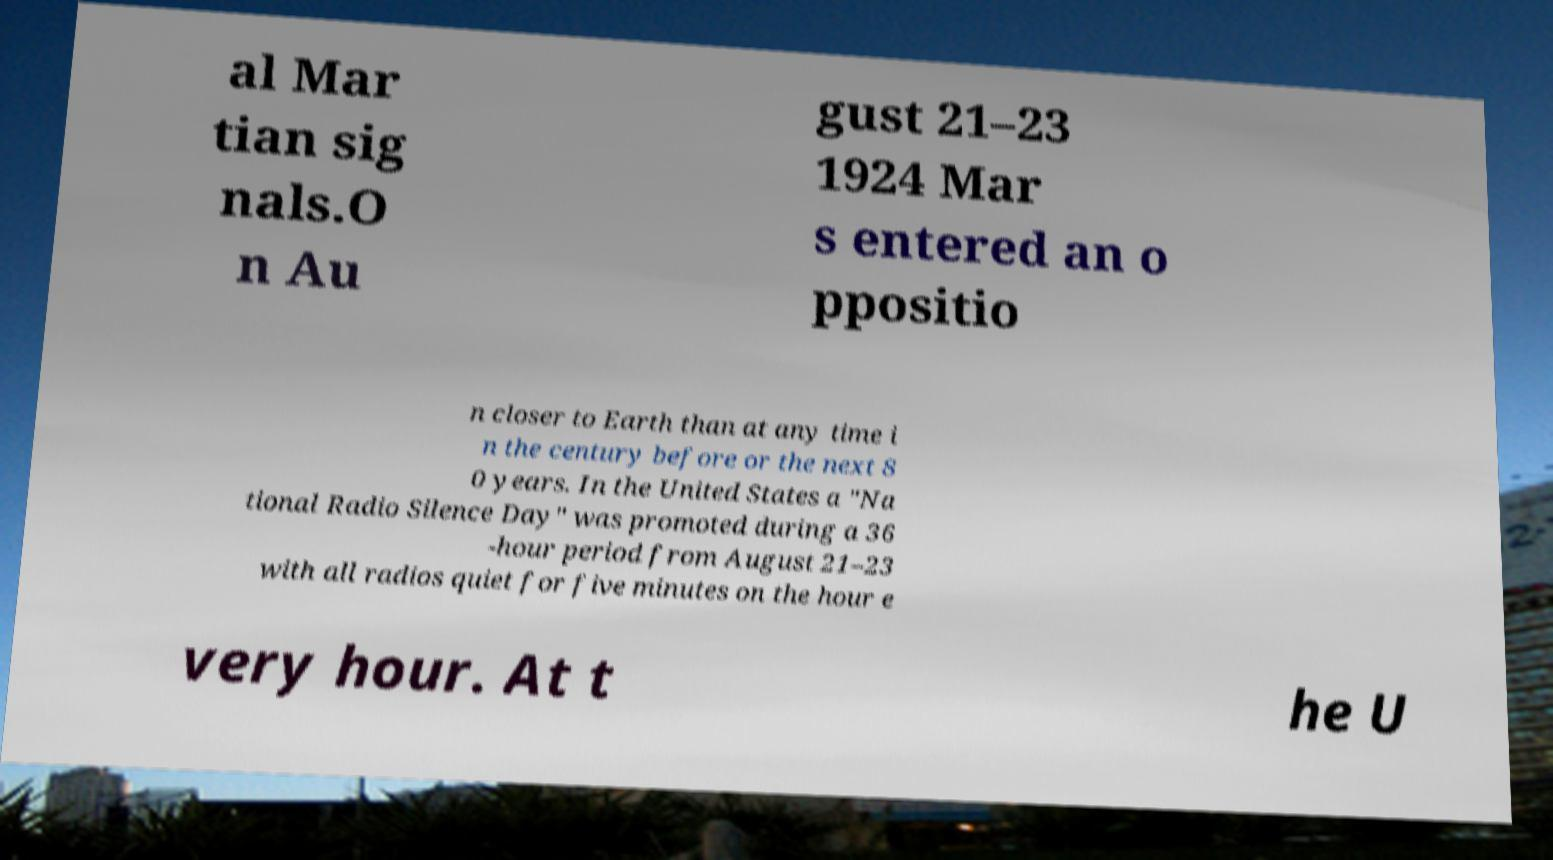Can you read and provide the text displayed in the image?This photo seems to have some interesting text. Can you extract and type it out for me? al Mar tian sig nals.O n Au gust 21–23 1924 Mar s entered an o ppositio n closer to Earth than at any time i n the century before or the next 8 0 years. In the United States a "Na tional Radio Silence Day" was promoted during a 36 -hour period from August 21–23 with all radios quiet for five minutes on the hour e very hour. At t he U 